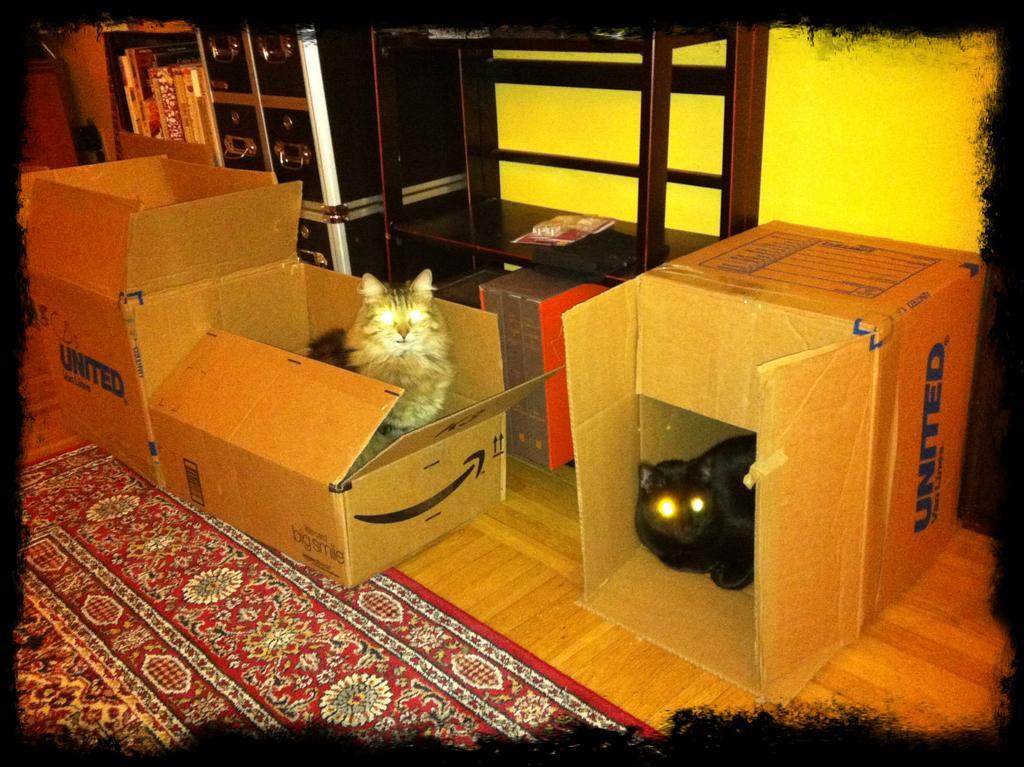In one or two sentences, can you explain what this image depicts? In this image there are some boxes and in the boxes there are cats, at the bottom there is floor. On the floor there is carpet, and in the background there are some shelves and some books and some other objects and wall. 